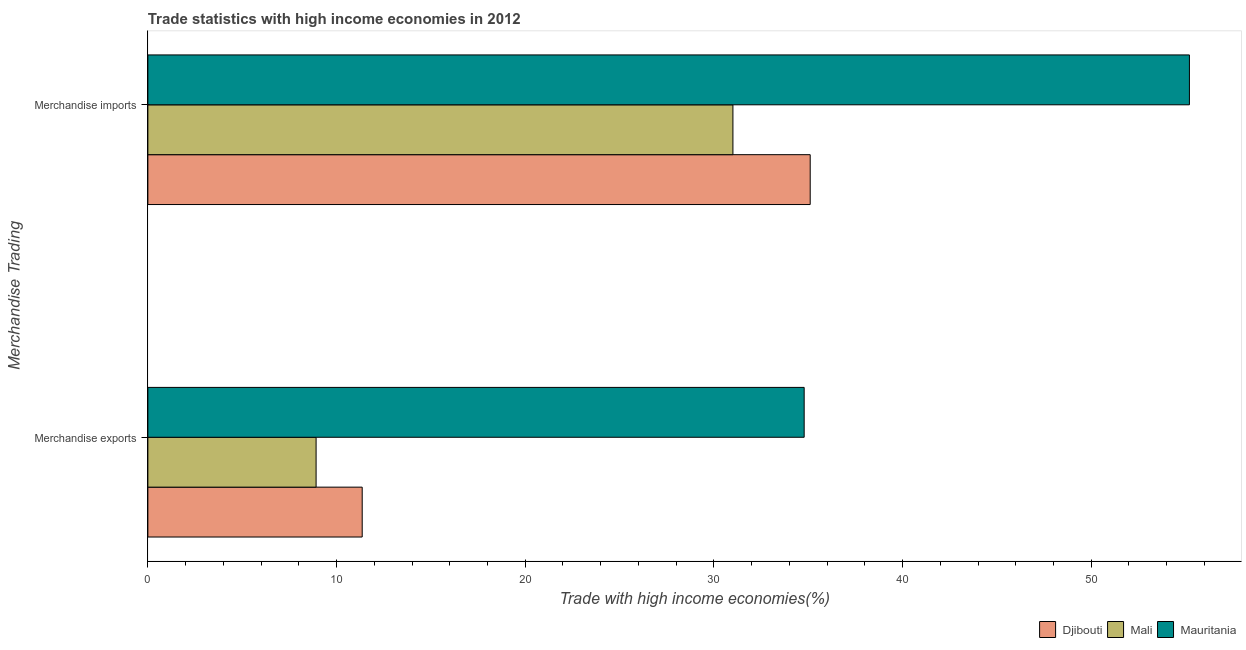How many groups of bars are there?
Give a very brief answer. 2. Are the number of bars per tick equal to the number of legend labels?
Keep it short and to the point. Yes. Are the number of bars on each tick of the Y-axis equal?
Ensure brevity in your answer.  Yes. How many bars are there on the 2nd tick from the bottom?
Provide a short and direct response. 3. What is the merchandise exports in Djibouti?
Your answer should be very brief. 11.36. Across all countries, what is the maximum merchandise exports?
Offer a very short reply. 34.79. Across all countries, what is the minimum merchandise imports?
Offer a terse response. 31.01. In which country was the merchandise exports maximum?
Make the answer very short. Mauritania. In which country was the merchandise imports minimum?
Your answer should be compact. Mali. What is the total merchandise imports in the graph?
Provide a succinct answer. 121.32. What is the difference between the merchandise imports in Djibouti and that in Mali?
Your answer should be compact. 4.1. What is the difference between the merchandise exports in Mauritania and the merchandise imports in Mali?
Ensure brevity in your answer.  3.78. What is the average merchandise exports per country?
Provide a short and direct response. 18.35. What is the difference between the merchandise exports and merchandise imports in Mauritania?
Keep it short and to the point. -20.42. In how many countries, is the merchandise imports greater than 12 %?
Keep it short and to the point. 3. What is the ratio of the merchandise exports in Mauritania to that in Mali?
Provide a succinct answer. 3.9. Is the merchandise exports in Mauritania less than that in Djibouti?
Offer a terse response. No. In how many countries, is the merchandise exports greater than the average merchandise exports taken over all countries?
Keep it short and to the point. 1. What does the 2nd bar from the top in Merchandise exports represents?
Your answer should be very brief. Mali. What does the 2nd bar from the bottom in Merchandise imports represents?
Keep it short and to the point. Mali. How many bars are there?
Provide a short and direct response. 6. Are all the bars in the graph horizontal?
Offer a very short reply. Yes. Are the values on the major ticks of X-axis written in scientific E-notation?
Make the answer very short. No. Does the graph contain grids?
Offer a very short reply. No. How many legend labels are there?
Your response must be concise. 3. How are the legend labels stacked?
Your answer should be very brief. Horizontal. What is the title of the graph?
Your answer should be compact. Trade statistics with high income economies in 2012. Does "Liechtenstein" appear as one of the legend labels in the graph?
Make the answer very short. No. What is the label or title of the X-axis?
Keep it short and to the point. Trade with high income economies(%). What is the label or title of the Y-axis?
Your answer should be very brief. Merchandise Trading. What is the Trade with high income economies(%) in Djibouti in Merchandise exports?
Your answer should be very brief. 11.36. What is the Trade with high income economies(%) of Mali in Merchandise exports?
Your answer should be very brief. 8.92. What is the Trade with high income economies(%) in Mauritania in Merchandise exports?
Give a very brief answer. 34.79. What is the Trade with high income economies(%) in Djibouti in Merchandise imports?
Provide a succinct answer. 35.11. What is the Trade with high income economies(%) in Mali in Merchandise imports?
Offer a terse response. 31.01. What is the Trade with high income economies(%) of Mauritania in Merchandise imports?
Provide a succinct answer. 55.21. Across all Merchandise Trading, what is the maximum Trade with high income economies(%) of Djibouti?
Provide a succinct answer. 35.11. Across all Merchandise Trading, what is the maximum Trade with high income economies(%) in Mali?
Your answer should be very brief. 31.01. Across all Merchandise Trading, what is the maximum Trade with high income economies(%) of Mauritania?
Provide a short and direct response. 55.21. Across all Merchandise Trading, what is the minimum Trade with high income economies(%) of Djibouti?
Your answer should be compact. 11.36. Across all Merchandise Trading, what is the minimum Trade with high income economies(%) of Mali?
Give a very brief answer. 8.92. Across all Merchandise Trading, what is the minimum Trade with high income economies(%) in Mauritania?
Provide a succinct answer. 34.79. What is the total Trade with high income economies(%) in Djibouti in the graph?
Offer a terse response. 46.47. What is the total Trade with high income economies(%) of Mali in the graph?
Give a very brief answer. 39.93. What is the total Trade with high income economies(%) of Mauritania in the graph?
Ensure brevity in your answer.  89.99. What is the difference between the Trade with high income economies(%) in Djibouti in Merchandise exports and that in Merchandise imports?
Offer a very short reply. -23.75. What is the difference between the Trade with high income economies(%) in Mali in Merchandise exports and that in Merchandise imports?
Give a very brief answer. -22.09. What is the difference between the Trade with high income economies(%) in Mauritania in Merchandise exports and that in Merchandise imports?
Make the answer very short. -20.42. What is the difference between the Trade with high income economies(%) in Djibouti in Merchandise exports and the Trade with high income economies(%) in Mali in Merchandise imports?
Make the answer very short. -19.65. What is the difference between the Trade with high income economies(%) of Djibouti in Merchandise exports and the Trade with high income economies(%) of Mauritania in Merchandise imports?
Offer a terse response. -43.84. What is the difference between the Trade with high income economies(%) in Mali in Merchandise exports and the Trade with high income economies(%) in Mauritania in Merchandise imports?
Provide a short and direct response. -46.29. What is the average Trade with high income economies(%) of Djibouti per Merchandise Trading?
Your response must be concise. 23.23. What is the average Trade with high income economies(%) of Mali per Merchandise Trading?
Your response must be concise. 19.96. What is the average Trade with high income economies(%) of Mauritania per Merchandise Trading?
Ensure brevity in your answer.  45. What is the difference between the Trade with high income economies(%) in Djibouti and Trade with high income economies(%) in Mali in Merchandise exports?
Ensure brevity in your answer.  2.44. What is the difference between the Trade with high income economies(%) of Djibouti and Trade with high income economies(%) of Mauritania in Merchandise exports?
Ensure brevity in your answer.  -23.43. What is the difference between the Trade with high income economies(%) of Mali and Trade with high income economies(%) of Mauritania in Merchandise exports?
Ensure brevity in your answer.  -25.87. What is the difference between the Trade with high income economies(%) in Djibouti and Trade with high income economies(%) in Mali in Merchandise imports?
Provide a succinct answer. 4.1. What is the difference between the Trade with high income economies(%) of Djibouti and Trade with high income economies(%) of Mauritania in Merchandise imports?
Offer a terse response. -20.1. What is the difference between the Trade with high income economies(%) in Mali and Trade with high income economies(%) in Mauritania in Merchandise imports?
Your answer should be very brief. -24.2. What is the ratio of the Trade with high income economies(%) of Djibouti in Merchandise exports to that in Merchandise imports?
Your answer should be very brief. 0.32. What is the ratio of the Trade with high income economies(%) in Mali in Merchandise exports to that in Merchandise imports?
Give a very brief answer. 0.29. What is the ratio of the Trade with high income economies(%) in Mauritania in Merchandise exports to that in Merchandise imports?
Your response must be concise. 0.63. What is the difference between the highest and the second highest Trade with high income economies(%) in Djibouti?
Ensure brevity in your answer.  23.75. What is the difference between the highest and the second highest Trade with high income economies(%) in Mali?
Offer a very short reply. 22.09. What is the difference between the highest and the second highest Trade with high income economies(%) in Mauritania?
Provide a succinct answer. 20.42. What is the difference between the highest and the lowest Trade with high income economies(%) of Djibouti?
Provide a succinct answer. 23.75. What is the difference between the highest and the lowest Trade with high income economies(%) of Mali?
Your response must be concise. 22.09. What is the difference between the highest and the lowest Trade with high income economies(%) of Mauritania?
Provide a short and direct response. 20.42. 